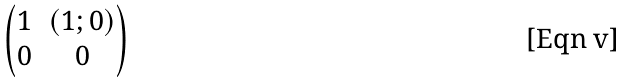Convert formula to latex. <formula><loc_0><loc_0><loc_500><loc_500>\begin{pmatrix} 1 & ( 1 ; 0 ) \\ 0 & 0 \end{pmatrix}</formula> 